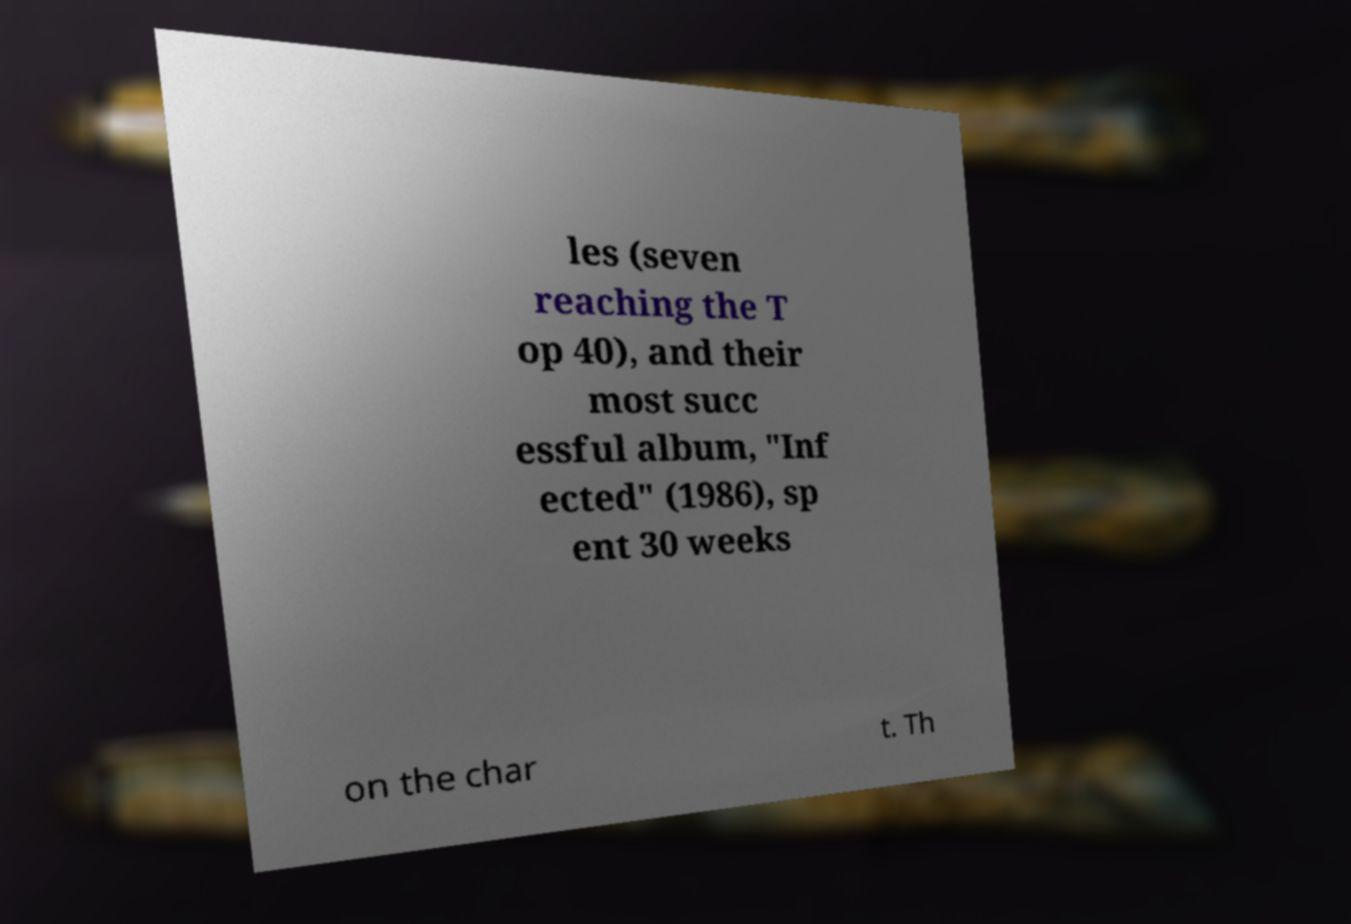Can you accurately transcribe the text from the provided image for me? les (seven reaching the T op 40), and their most succ essful album, "Inf ected" (1986), sp ent 30 weeks on the char t. Th 